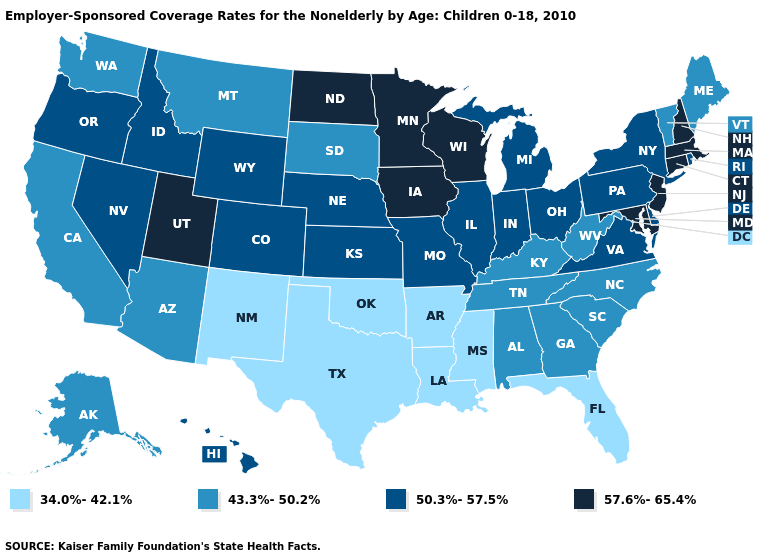What is the value of Arizona?
Concise answer only. 43.3%-50.2%. Does Delaware have the highest value in the USA?
Answer briefly. No. How many symbols are there in the legend?
Give a very brief answer. 4. Does Georgia have the highest value in the USA?
Keep it brief. No. What is the highest value in the USA?
Short answer required. 57.6%-65.4%. Name the states that have a value in the range 34.0%-42.1%?
Quick response, please. Arkansas, Florida, Louisiana, Mississippi, New Mexico, Oklahoma, Texas. Does Maryland have the highest value in the South?
Be succinct. Yes. Which states have the lowest value in the USA?
Keep it brief. Arkansas, Florida, Louisiana, Mississippi, New Mexico, Oklahoma, Texas. Does Maine have the highest value in the Northeast?
Short answer required. No. What is the highest value in states that border Idaho?
Give a very brief answer. 57.6%-65.4%. Which states have the highest value in the USA?
Keep it brief. Connecticut, Iowa, Maryland, Massachusetts, Minnesota, New Hampshire, New Jersey, North Dakota, Utah, Wisconsin. Name the states that have a value in the range 57.6%-65.4%?
Give a very brief answer. Connecticut, Iowa, Maryland, Massachusetts, Minnesota, New Hampshire, New Jersey, North Dakota, Utah, Wisconsin. Name the states that have a value in the range 57.6%-65.4%?
Concise answer only. Connecticut, Iowa, Maryland, Massachusetts, Minnesota, New Hampshire, New Jersey, North Dakota, Utah, Wisconsin. 